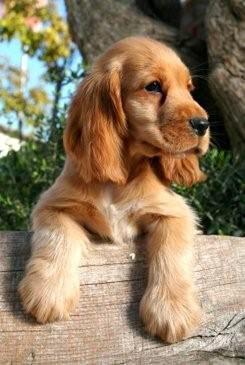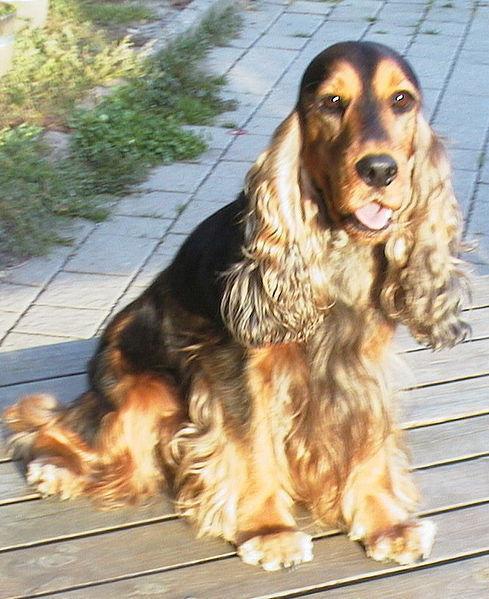The first image is the image on the left, the second image is the image on the right. Assess this claim about the two images: "An image shows a gold-colored puppy with at least one paw draped over something.". Correct or not? Answer yes or no. Yes. The first image is the image on the left, the second image is the image on the right. For the images displayed, is the sentence "One of the images contains a dog only showing its two front legs." factually correct? Answer yes or no. Yes. 